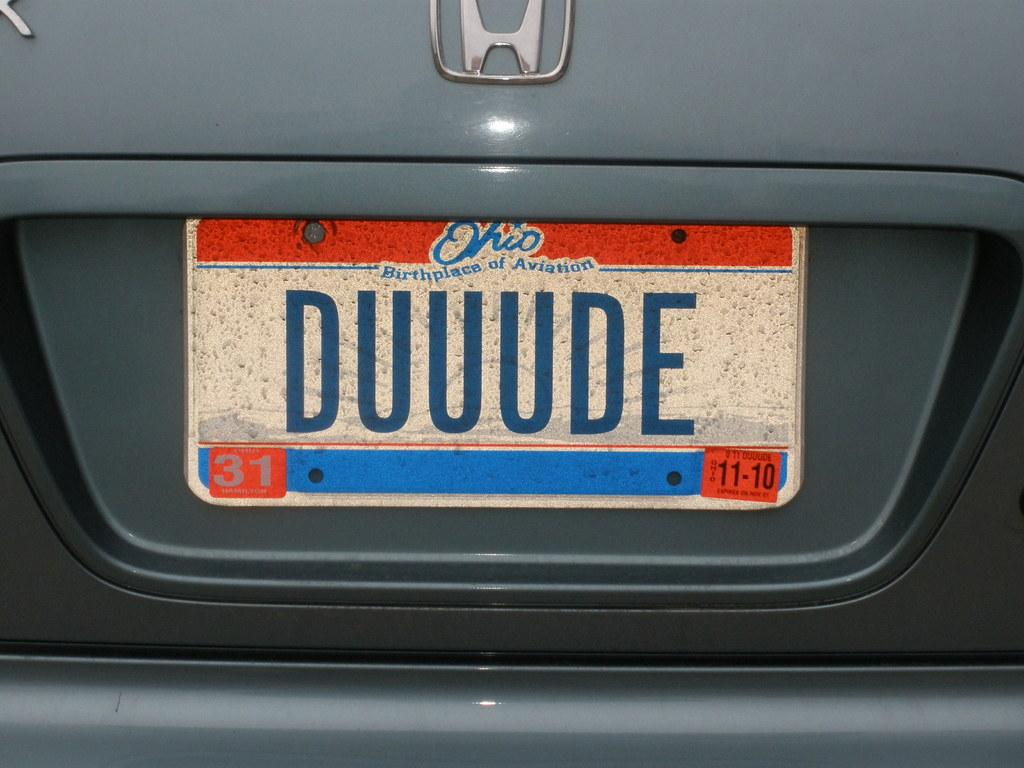<image>
Create a compact narrative representing the image presented. A red and blue license plate from Ohio says Duuude on it. 